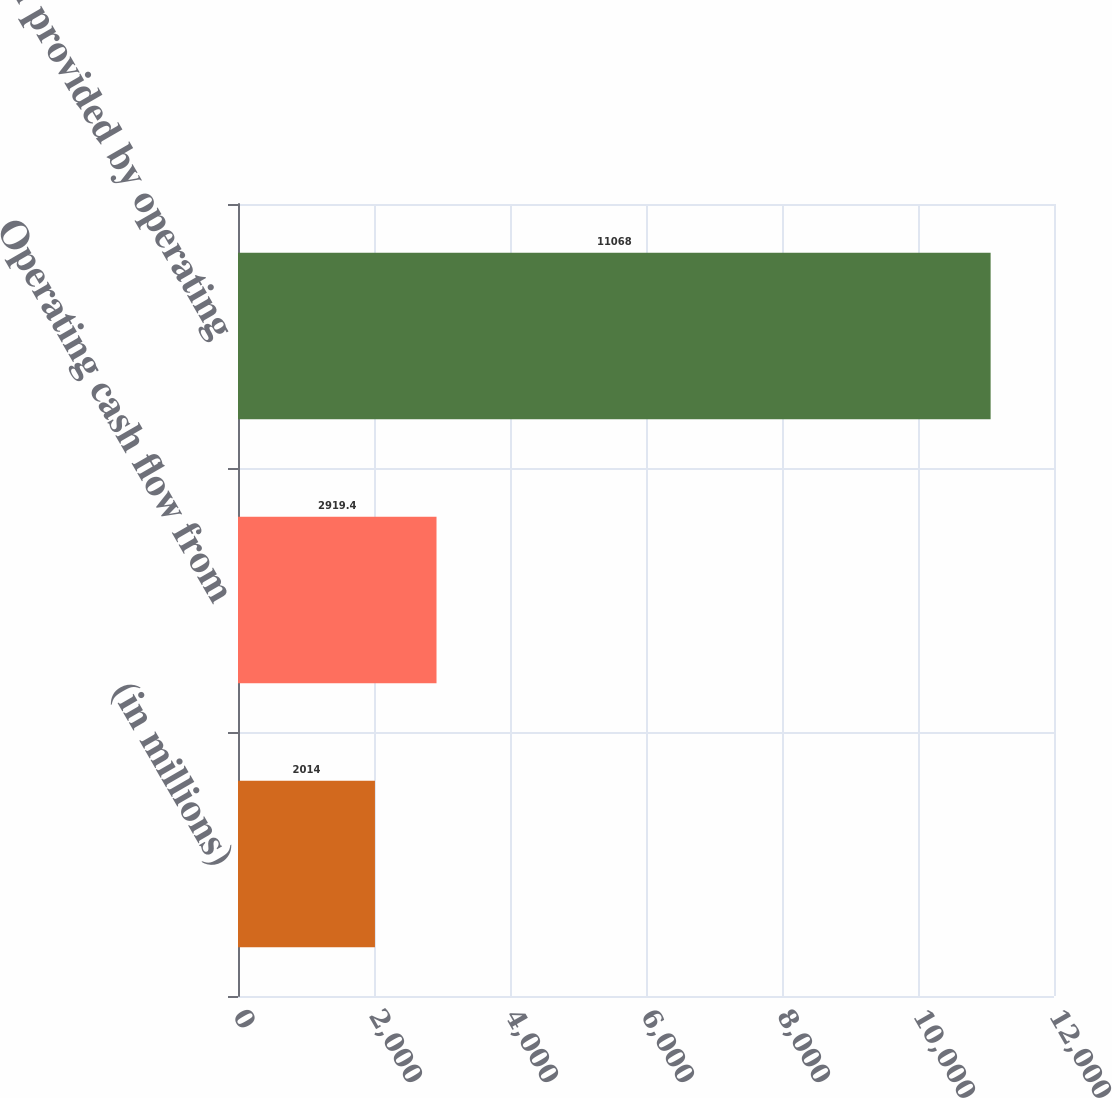<chart> <loc_0><loc_0><loc_500><loc_500><bar_chart><fcel>(in millions)<fcel>Operating cash flow from<fcel>Net cash provided by operating<nl><fcel>2014<fcel>2919.4<fcel>11068<nl></chart> 